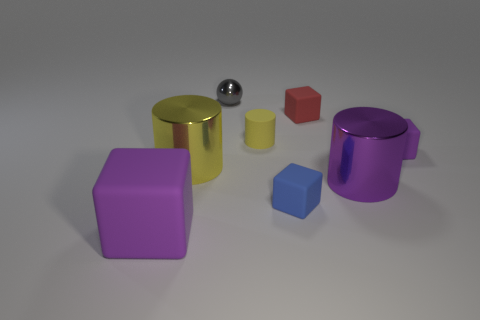Add 1 tiny blocks. How many objects exist? 9 Subtract all cylinders. How many objects are left? 5 Subtract 1 purple cylinders. How many objects are left? 7 Subtract all rubber cylinders. Subtract all gray balls. How many objects are left? 6 Add 6 matte cylinders. How many matte cylinders are left? 7 Add 7 large red rubber cylinders. How many large red rubber cylinders exist? 7 